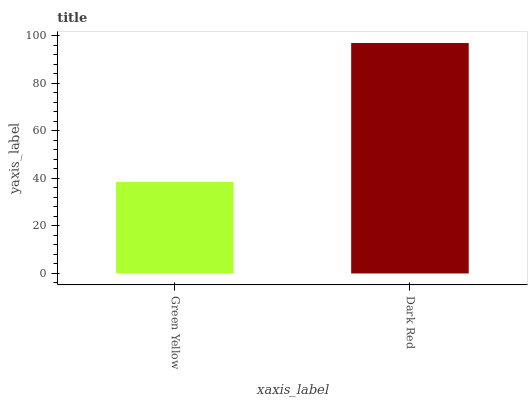Is Dark Red the minimum?
Answer yes or no. No. Is Dark Red greater than Green Yellow?
Answer yes or no. Yes. Is Green Yellow less than Dark Red?
Answer yes or no. Yes. Is Green Yellow greater than Dark Red?
Answer yes or no. No. Is Dark Red less than Green Yellow?
Answer yes or no. No. Is Dark Red the high median?
Answer yes or no. Yes. Is Green Yellow the low median?
Answer yes or no. Yes. Is Green Yellow the high median?
Answer yes or no. No. Is Dark Red the low median?
Answer yes or no. No. 